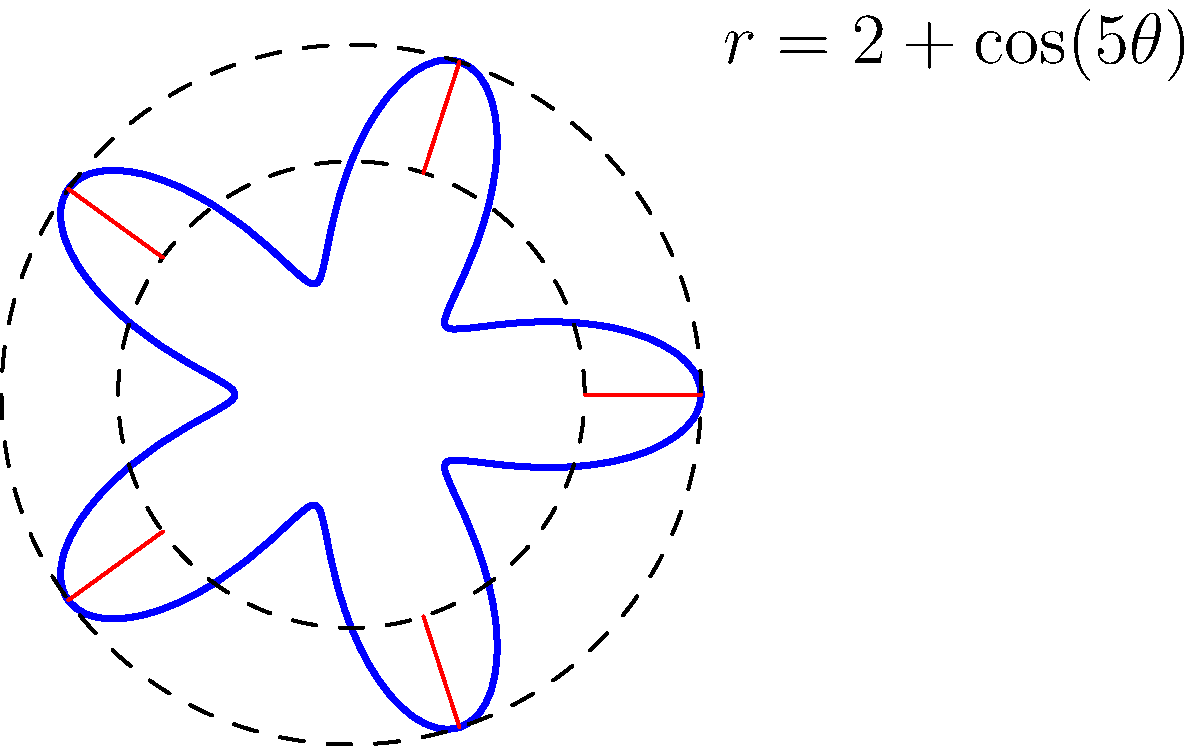You're designing a circular mandala-style logo for a fantasy movie. The client wants a flower-like pattern with 5 petals. You decide to use the polar equation $r = 2 + \cos(5\theta)$ to create the base shape. What is the maximum radius of this shape, and at which angles $\theta$ (in radians) does it occur? To solve this problem, let's follow these steps:

1) The polar equation is given as $r = 2 + \cos(5\theta)$.

2) The maximum radius will occur when $\cos(5\theta)$ is at its maximum value, which is 1.

3) When $\cos(5\theta) = 1$, the radius $r$ will be:
   $r = 2 + 1 = 3$

4) To find the angles at which this maximum occurs, we need to solve:
   $\cos(5\theta) = 1$

5) This occurs when $5\theta = 0, 2\pi, 4\pi, ...$, or more generally, when $5\theta = 2\pi n$ where $n$ is any integer.

6) Solving for $\theta$:
   $\theta = \frac{2\pi n}{5}$, where $n = 0, 1, 2, 3, 4$

7) This gives us the angles:
   $\theta = 0, \frac{2\pi}{5}, \frac{4\pi}{5}, \frac{6\pi}{5}, \frac{8\pi}{5}$

8) These angles correspond to the five tips of the petals in the mandala design.

Therefore, the maximum radius is 3 units, occurring at angles $0, \frac{2\pi}{5}, \frac{4\pi}{5}, \frac{6\pi}{5}, \frac{8\pi}{5}$ radians.
Answer: Maximum radius: 3; Angles: $0, \frac{2\pi}{5}, \frac{4\pi}{5}, \frac{6\pi}{5}, \frac{8\pi}{5}$ radians 